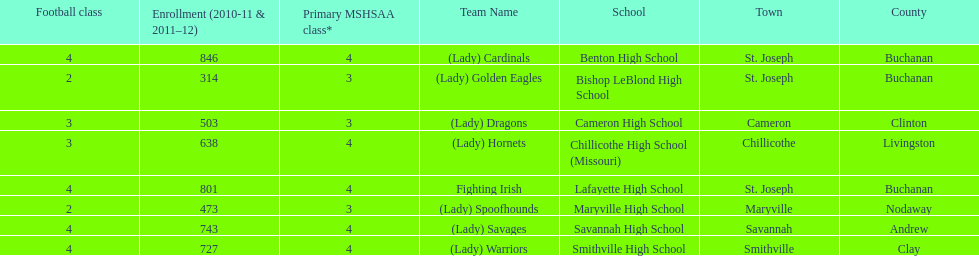How many of the schools had at least 500 students enrolled in the 2010-2011 and 2011-2012 season? 6. 